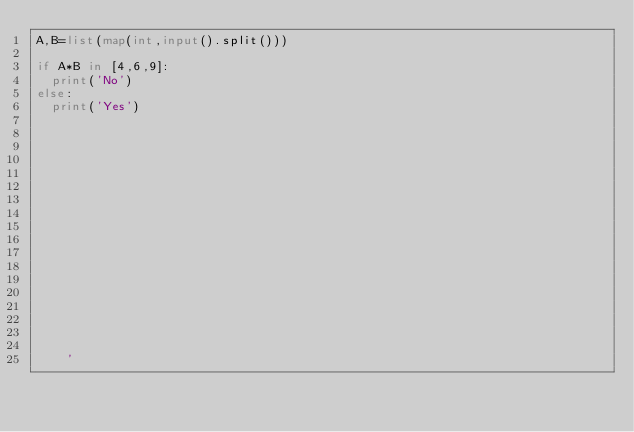<code> <loc_0><loc_0><loc_500><loc_500><_Python_>A,B=list(map(int,input().split()))

if A*B in [4,6,9]:
  print('No')
else:
  print('Yes')
    
    
    
    
    
    
    
    
    
    
    
    
    
    
    
    
    
    
    '</code> 